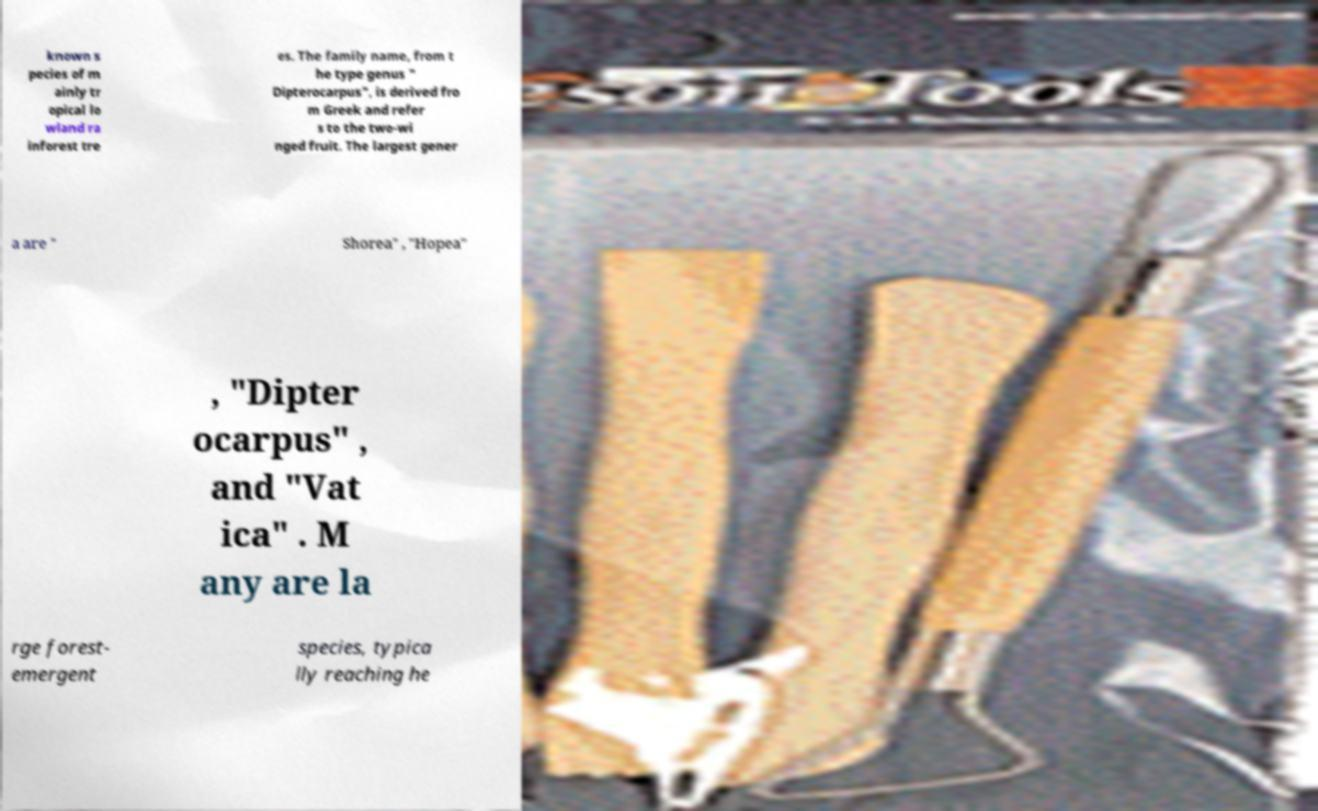What messages or text are displayed in this image? I need them in a readable, typed format. known s pecies of m ainly tr opical lo wland ra inforest tre es. The family name, from t he type genus " Dipterocarpus", is derived fro m Greek and refer s to the two-wi nged fruit. The largest gener a are " Shorea" , "Hopea" , "Dipter ocarpus" , and "Vat ica" . M any are la rge forest- emergent species, typica lly reaching he 